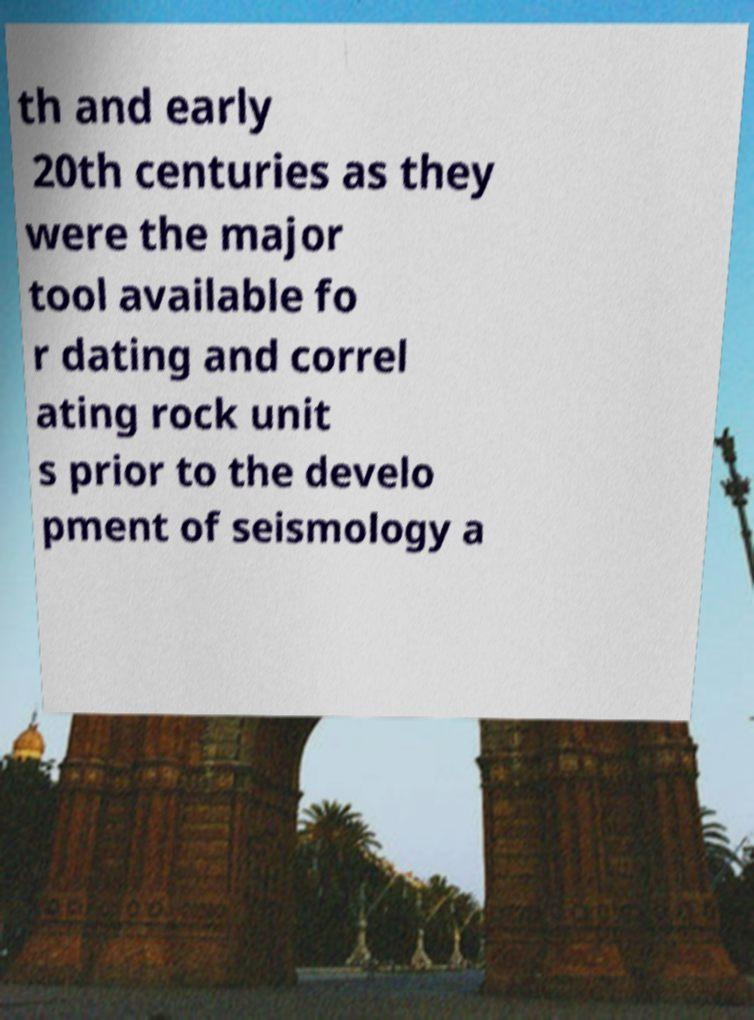There's text embedded in this image that I need extracted. Can you transcribe it verbatim? th and early 20th centuries as they were the major tool available fo r dating and correl ating rock unit s prior to the develo pment of seismology a 